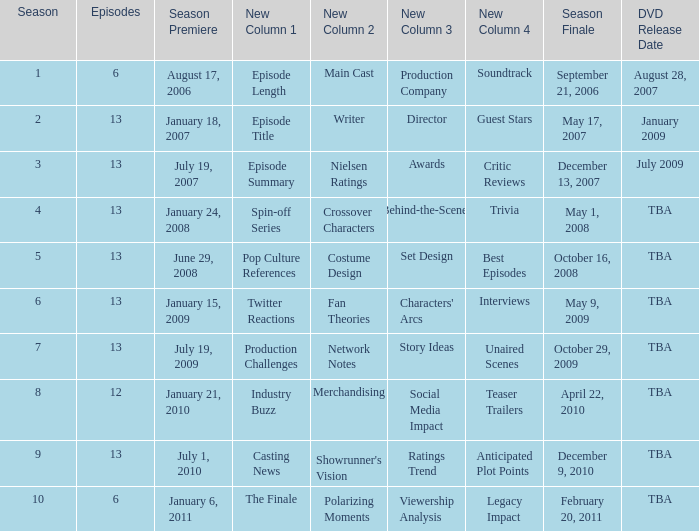Would you be able to parse every entry in this table? {'header': ['Season', 'Episodes', 'Season Premiere', 'New Column 1', 'New Column 2', 'New Column 3', 'New Column 4', 'Season Finale', 'DVD Release Date'], 'rows': [['1', '6', 'August 17, 2006', 'Episode Length', 'Main Cast', 'Production Company', 'Soundtrack', 'September 21, 2006', 'August 28, 2007'], ['2', '13', 'January 18, 2007', 'Episode Title', 'Writer', 'Director', 'Guest Stars', 'May 17, 2007', 'January 2009'], ['3', '13', 'July 19, 2007', 'Episode Summary', 'Nielsen Ratings', 'Awards', 'Critic Reviews', 'December 13, 2007', 'July 2009'], ['4', '13', 'January 24, 2008', 'Spin-off Series', 'Crossover Characters', 'Behind-the-Scenes', 'Trivia', 'May 1, 2008', 'TBA'], ['5', '13', 'June 29, 2008', 'Pop Culture References', 'Costume Design', 'Set Design', 'Best Episodes', 'October 16, 2008', 'TBA'], ['6', '13', 'January 15, 2009', 'Twitter Reactions', 'Fan Theories', "Characters' Arcs", 'Interviews', 'May 9, 2009', 'TBA'], ['7', '13', 'July 19, 2009', 'Production Challenges', 'Network Notes', 'Story Ideas', 'Unaired Scenes', 'October 29, 2009', 'TBA'], ['8', '12', 'January 21, 2010', 'Industry Buzz', 'Merchandising', 'Social Media Impact', 'Teaser Trailers', 'April 22, 2010', 'TBA'], ['9', '13', 'July 1, 2010', 'Casting News', "Showrunner's Vision", 'Ratings Trend', 'Anticipated Plot Points', 'December 9, 2010', 'TBA'], ['10', '6', 'January 6, 2011', 'The Finale', 'Polarizing Moments', 'Viewership Analysis', 'Legacy Impact', 'February 20, 2011', 'TBA']]} When was the dvd launch date for the season having less than 13 episodes and aired prior to season 8? August 28, 2007. 